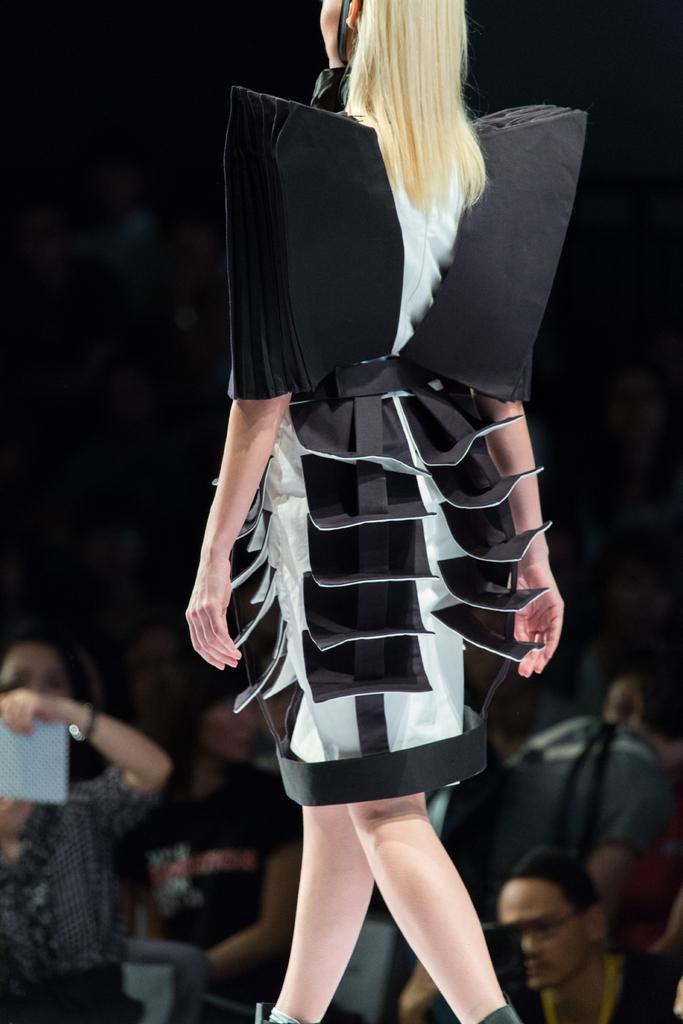How would you summarize this image in a sentence or two? This woman wear dress and walking. Background we can see audience.  